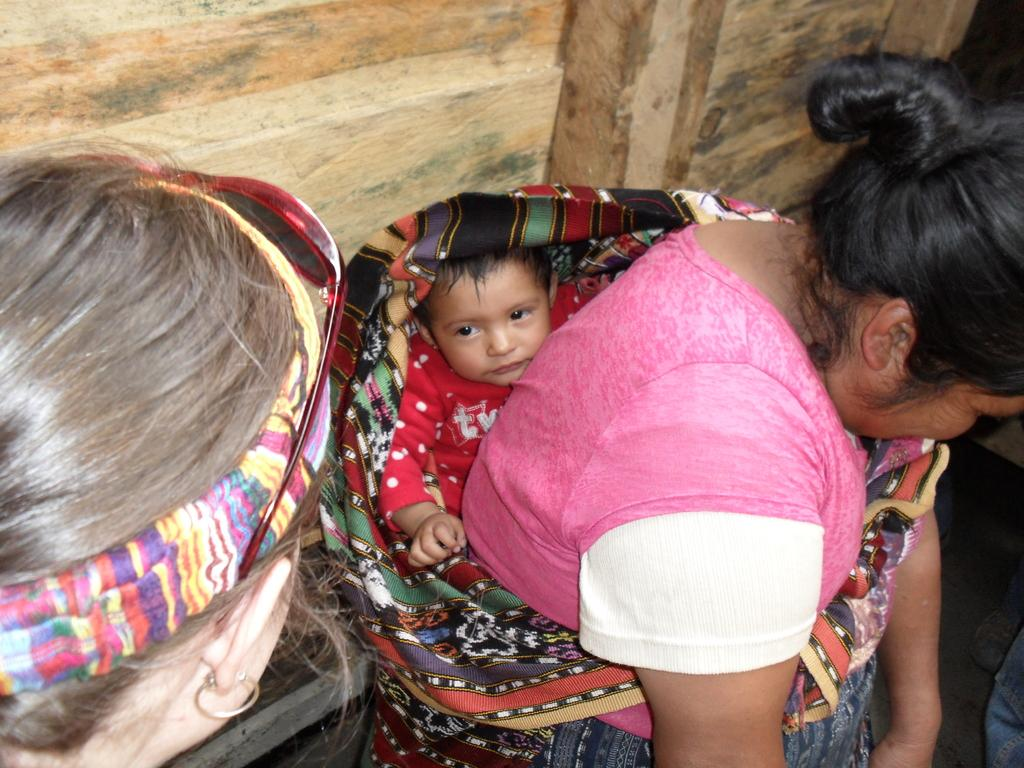What is the main subject of the image? The main subject of the image is persons in the center. Can you describe the interaction between the persons in the center? A woman is holding a child in the center of the image. What type of screw can be seen in the image? There is no screw present in the image. What is the purpose of the cabbage in the image? There is no cabbage present in the image. 